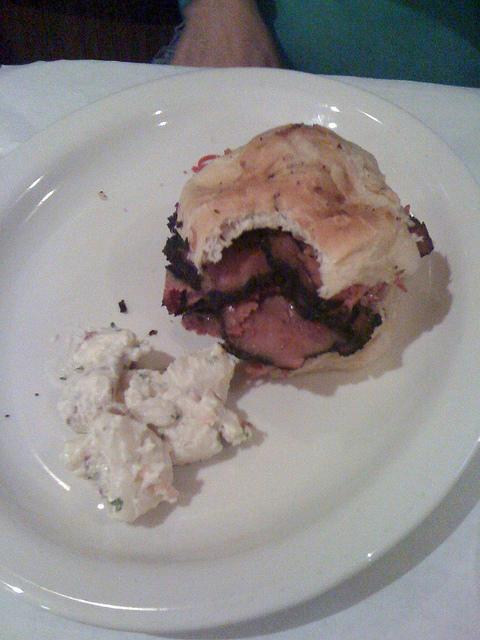How many cakes are visible?
Give a very brief answer. 2. How many people are in the photo?
Give a very brief answer. 1. 